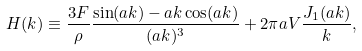Convert formula to latex. <formula><loc_0><loc_0><loc_500><loc_500>H ( k ) \equiv \frac { 3 F } { \rho } \frac { \sin ( a k ) - a k \cos ( a k ) } { ( a k ) ^ { 3 } } + 2 \pi a V \frac { J _ { 1 } ( a k ) } { k } ,</formula> 